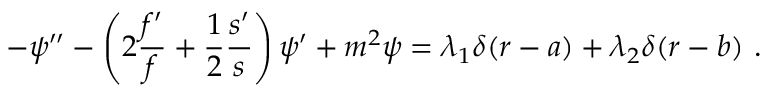<formula> <loc_0><loc_0><loc_500><loc_500>- \psi ^ { \prime \prime } - \left ( 2 \frac { f ^ { \prime } } { f } + \frac { 1 } { 2 } \frac { s ^ { \prime } } { s } \right ) \psi ^ { \prime } + m ^ { 2 } \psi = \lambda _ { 1 } \delta ( r - a ) + \lambda _ { 2 } \delta ( r - b ) \ .</formula> 